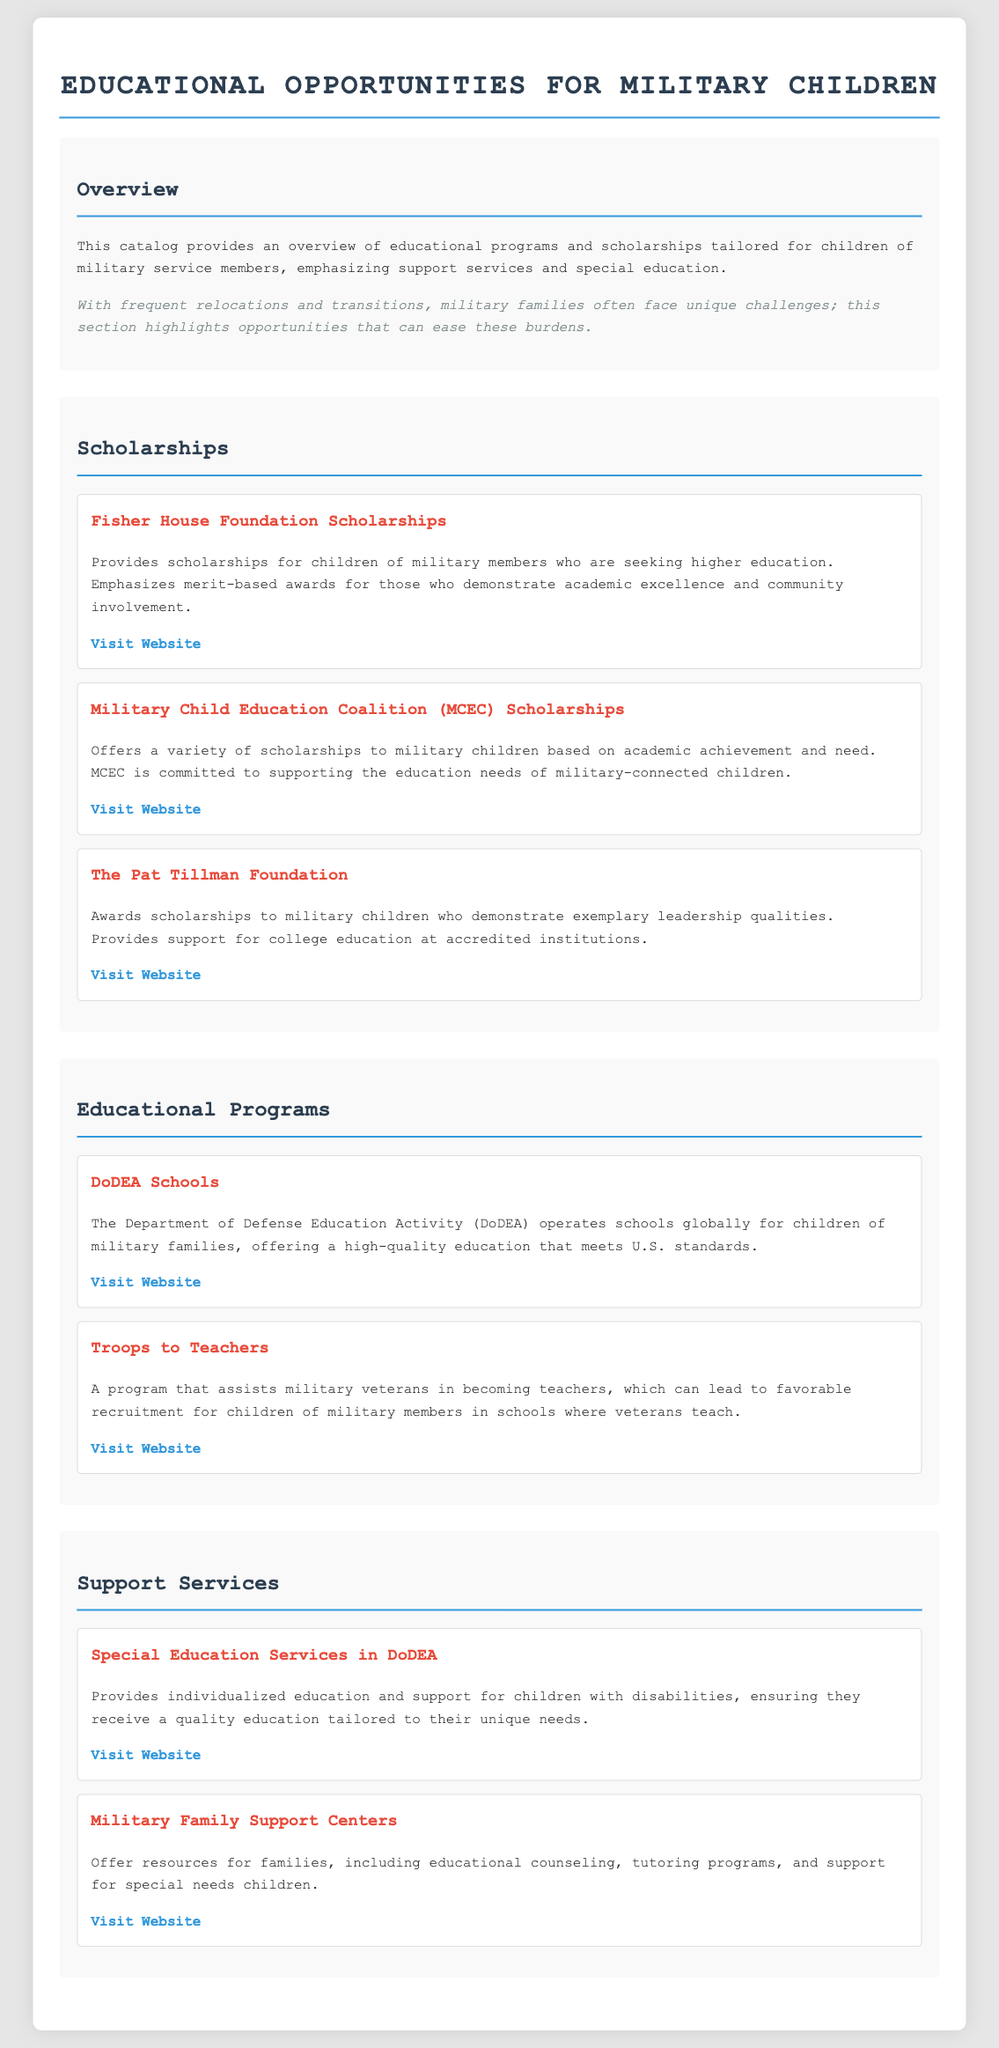What is the title of the catalog? The title is provided in the header of the document.
Answer: Educational Opportunities for Military Children What organization offers scholarships based on academic achievement and need? The organization is named in the scholarship section.
Answer: Military Child Education Coalition What does DoDEA stand for? This acronym is introduced in the educational programs section of the document.
Answer: Department of Defense Education Activity What type of services do Military Family Support Centers offer? The document specifies the services available in the support services section.
Answer: Educational counseling Which foundation provides scholarships that emphasize merit-based awards? This detail is highlighted in the scholarships section.
Answer: Fisher House Foundation Scholarships What is the main purpose of the Troops to Teachers program? The purpose is explained in the educational programs section, requiring reasoning based on its description.
Answer: Assists military veterans in becoming teachers What kind of education does DoDEA Schools provide? The type of education is stated in the respective section of the catalog.
Answer: High-quality education How does the document address the unique challenges faced by military families? The overview section mentions the impact of relocations and transitions on military families and solutions offered in the catalog.
Answer: Highlighting opportunities that can ease these burdens 